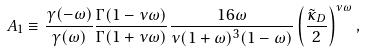Convert formula to latex. <formula><loc_0><loc_0><loc_500><loc_500>A _ { 1 } \equiv \frac { \gamma ( - \omega ) } { \gamma ( \omega ) } \frac { \Gamma ( 1 - \nu \omega ) } { \Gamma ( 1 + \nu \omega ) } \frac { 1 6 \omega } { \nu ( 1 + \omega ) ^ { 3 } ( 1 - \omega ) } \left ( \frac { \tilde { \kappa } _ { D } } { 2 } \right ) ^ { \nu \omega } ,</formula> 